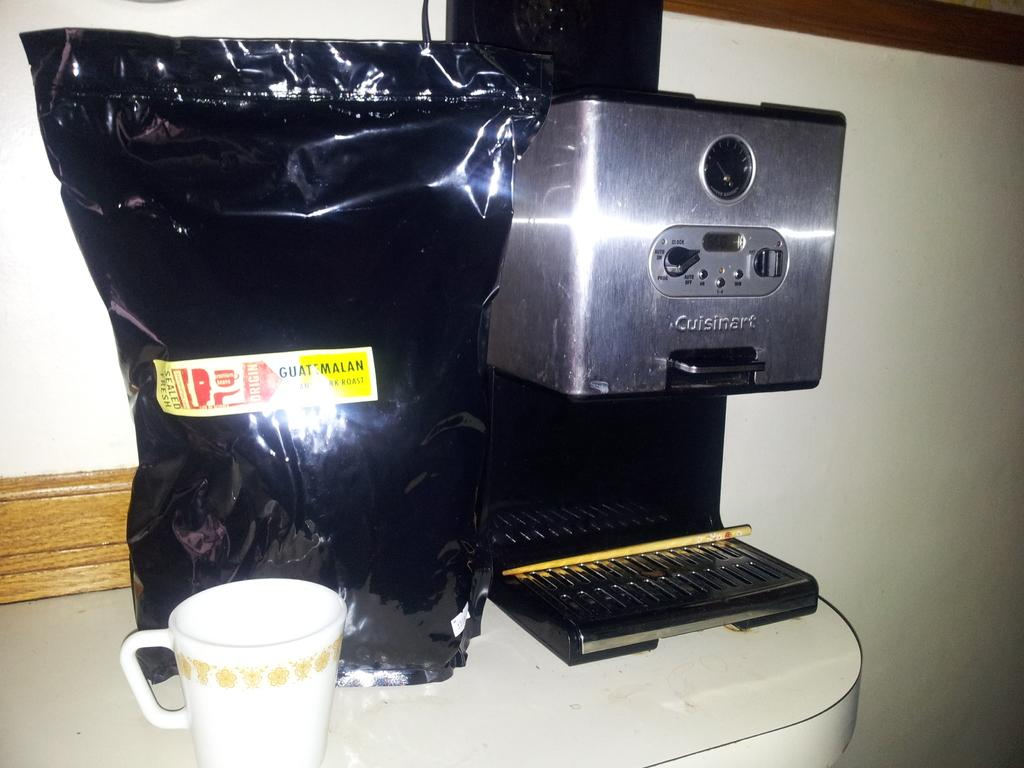<image>
Summarize the visual content of the image. A Cusinart brand coffee maker on a counter top with a white coffee cup beside a bag 